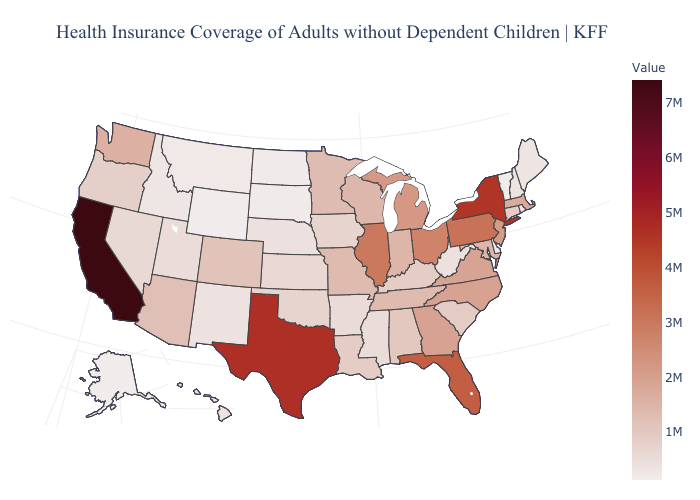Does Oregon have the lowest value in the USA?
Give a very brief answer. No. Among the states that border Idaho , which have the highest value?
Concise answer only. Washington. Which states have the highest value in the USA?
Give a very brief answer. California. Does California have a higher value than Tennessee?
Give a very brief answer. Yes. Which states have the lowest value in the Northeast?
Write a very short answer. Vermont. Among the states that border Texas , does Louisiana have the lowest value?
Be succinct. No. Among the states that border Ohio , which have the highest value?
Give a very brief answer. Pennsylvania. 